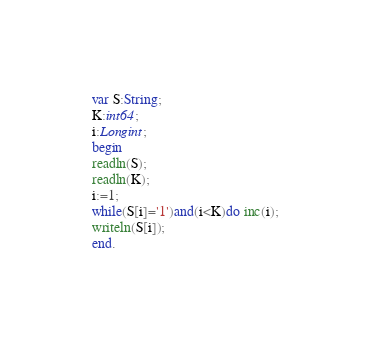Convert code to text. <code><loc_0><loc_0><loc_500><loc_500><_Pascal_>var S:String;
K:int64;
i:Longint;
begin
readln(S);
readln(K);
i:=1;
while(S[i]='1')and(i<K)do inc(i);
writeln(S[i]);
end.</code> 